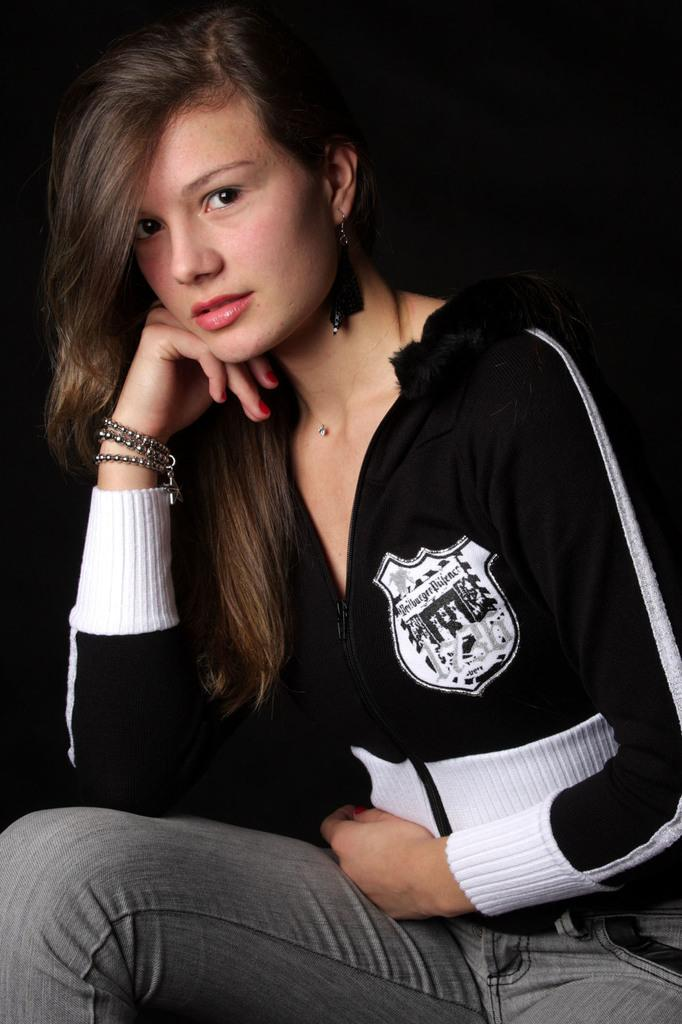Who is present in the image? There is a woman in the image. What is the woman wearing? The woman is wearing clothes, a bracelet, and earrings. What can be observed about the background of the image? The background of the image is dark. What type of cap can be seen on the woman's head in the image? There is no cap visible on the woman's head in the image. What smell is associated with the woman in the image? There is no information about any smell associated with the woman in the image. 